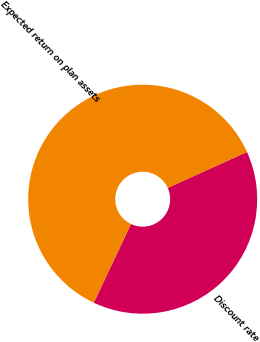<chart> <loc_0><loc_0><loc_500><loc_500><pie_chart><fcel>Discount rate<fcel>Expected return on plan assets<nl><fcel>38.8%<fcel>61.2%<nl></chart> 